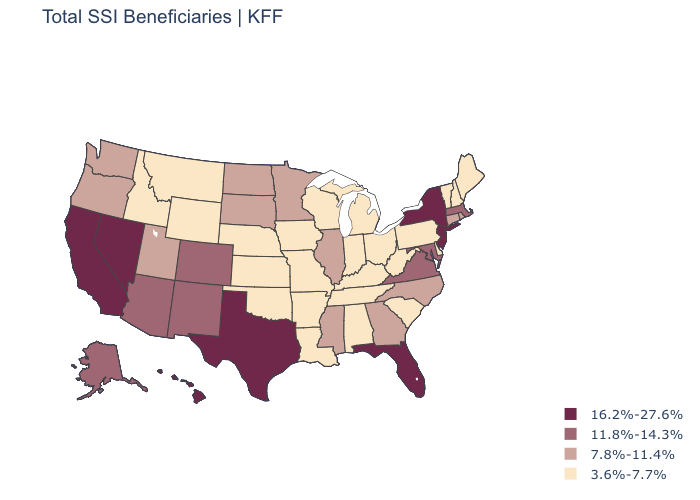Which states have the highest value in the USA?
Quick response, please. California, Florida, Hawaii, Nevada, New Jersey, New York, Texas. Name the states that have a value in the range 7.8%-11.4%?
Quick response, please. Connecticut, Georgia, Illinois, Minnesota, Mississippi, North Carolina, North Dakota, Oregon, Rhode Island, South Dakota, Utah, Washington. Does the first symbol in the legend represent the smallest category?
Write a very short answer. No. Among the states that border Kansas , which have the lowest value?
Concise answer only. Missouri, Nebraska, Oklahoma. Which states have the highest value in the USA?
Short answer required. California, Florida, Hawaii, Nevada, New Jersey, New York, Texas. Does Alaska have the highest value in the USA?
Answer briefly. No. Name the states that have a value in the range 7.8%-11.4%?
Quick response, please. Connecticut, Georgia, Illinois, Minnesota, Mississippi, North Carolina, North Dakota, Oregon, Rhode Island, South Dakota, Utah, Washington. Which states have the lowest value in the South?
Concise answer only. Alabama, Arkansas, Delaware, Kentucky, Louisiana, Oklahoma, South Carolina, Tennessee, West Virginia. What is the value of Delaware?
Be succinct. 3.6%-7.7%. Name the states that have a value in the range 11.8%-14.3%?
Short answer required. Alaska, Arizona, Colorado, Maryland, Massachusetts, New Mexico, Virginia. Which states have the lowest value in the USA?
Write a very short answer. Alabama, Arkansas, Delaware, Idaho, Indiana, Iowa, Kansas, Kentucky, Louisiana, Maine, Michigan, Missouri, Montana, Nebraska, New Hampshire, Ohio, Oklahoma, Pennsylvania, South Carolina, Tennessee, Vermont, West Virginia, Wisconsin, Wyoming. Does Oregon have the highest value in the USA?
Be succinct. No. Name the states that have a value in the range 11.8%-14.3%?
Concise answer only. Alaska, Arizona, Colorado, Maryland, Massachusetts, New Mexico, Virginia. Does the map have missing data?
Short answer required. No. 